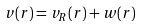<formula> <loc_0><loc_0><loc_500><loc_500>v ( r ) = v _ { R } ( r ) + w ( r )</formula> 